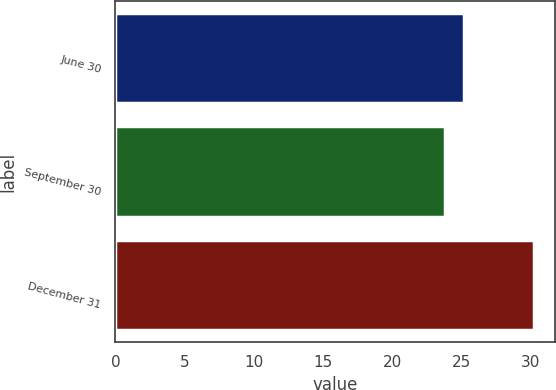<chart> <loc_0><loc_0><loc_500><loc_500><bar_chart><fcel>June 30<fcel>September 30<fcel>December 31<nl><fcel>25.2<fcel>23.8<fcel>30.3<nl></chart> 